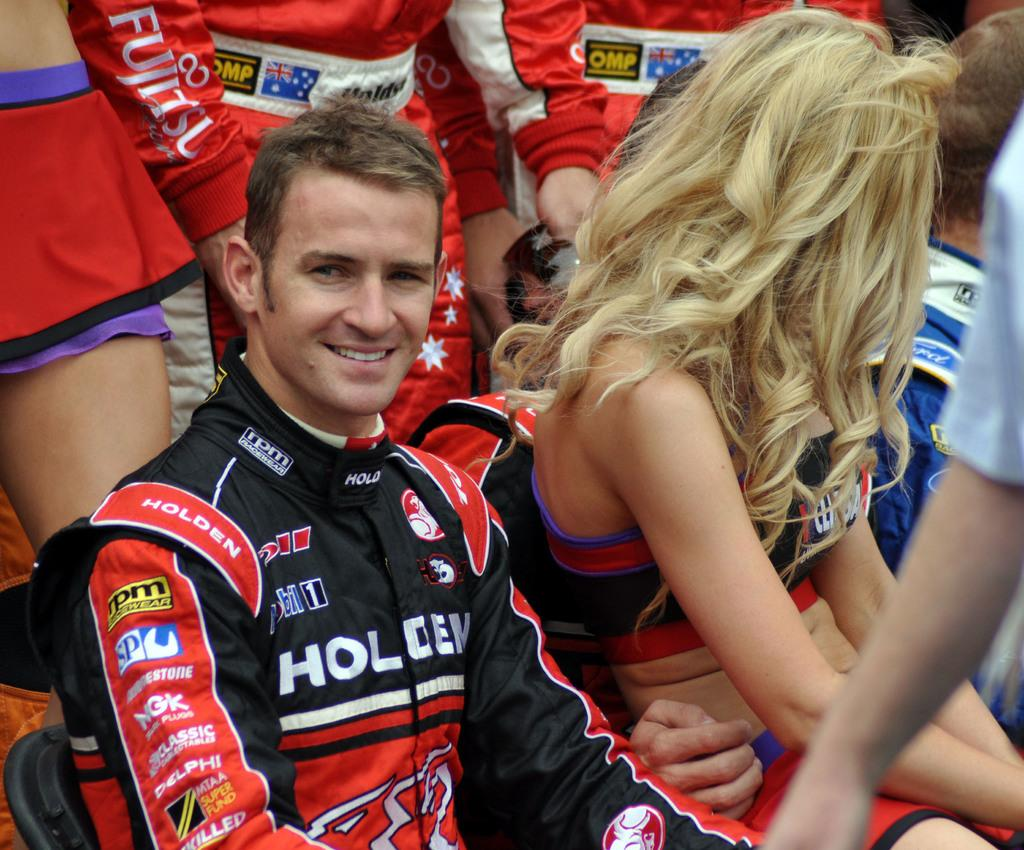Provide a one-sentence caption for the provided image. A race car driver whose suite reads "Holden" sits in the stands next to a cheerleader. 